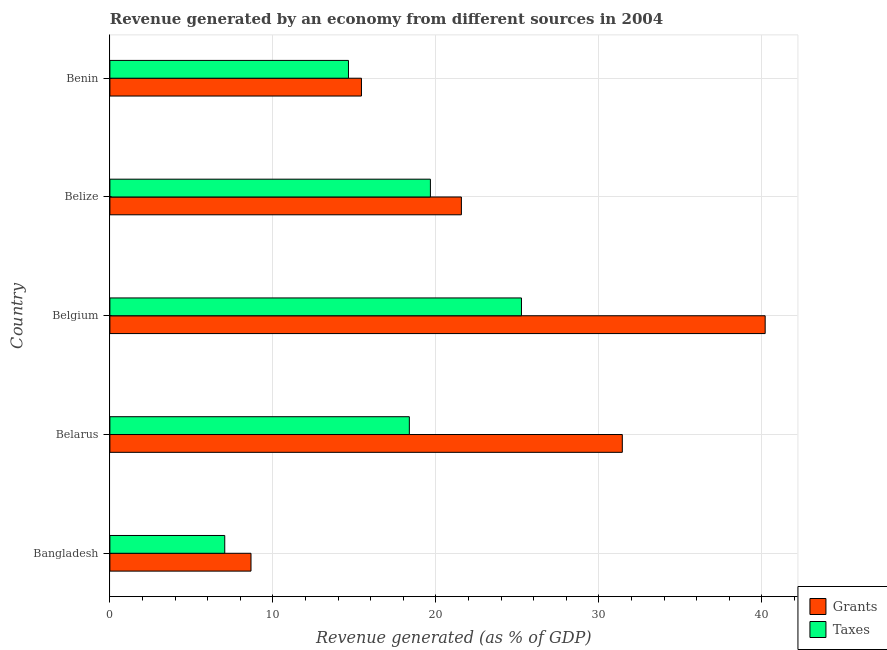How many different coloured bars are there?
Keep it short and to the point. 2. Are the number of bars per tick equal to the number of legend labels?
Your answer should be very brief. Yes. Are the number of bars on each tick of the Y-axis equal?
Offer a terse response. Yes. How many bars are there on the 3rd tick from the bottom?
Give a very brief answer. 2. What is the label of the 2nd group of bars from the top?
Your response must be concise. Belize. What is the revenue generated by grants in Benin?
Your response must be concise. 15.43. Across all countries, what is the maximum revenue generated by taxes?
Your answer should be very brief. 25.25. Across all countries, what is the minimum revenue generated by taxes?
Offer a very short reply. 7.05. What is the total revenue generated by taxes in the graph?
Your response must be concise. 84.97. What is the difference between the revenue generated by grants in Bangladesh and that in Belarus?
Ensure brevity in your answer.  -22.78. What is the difference between the revenue generated by grants in Belgium and the revenue generated by taxes in Belize?
Your response must be concise. 20.54. What is the average revenue generated by taxes per country?
Offer a terse response. 16.99. What is the ratio of the revenue generated by grants in Belarus to that in Benin?
Your answer should be compact. 2.04. Is the difference between the revenue generated by grants in Bangladesh and Belarus greater than the difference between the revenue generated by taxes in Bangladesh and Belarus?
Ensure brevity in your answer.  No. What is the difference between the highest and the second highest revenue generated by grants?
Provide a succinct answer. 8.76. Is the sum of the revenue generated by taxes in Bangladesh and Belgium greater than the maximum revenue generated by grants across all countries?
Your answer should be very brief. No. What does the 1st bar from the top in Benin represents?
Make the answer very short. Taxes. What does the 2nd bar from the bottom in Belize represents?
Provide a succinct answer. Taxes. How many bars are there?
Offer a terse response. 10. Are all the bars in the graph horizontal?
Provide a succinct answer. Yes. How many countries are there in the graph?
Offer a very short reply. 5. What is the difference between two consecutive major ticks on the X-axis?
Provide a succinct answer. 10. Are the values on the major ticks of X-axis written in scientific E-notation?
Your answer should be compact. No. Does the graph contain grids?
Offer a terse response. Yes. How are the legend labels stacked?
Ensure brevity in your answer.  Vertical. What is the title of the graph?
Your answer should be very brief. Revenue generated by an economy from different sources in 2004. Does "Savings" appear as one of the legend labels in the graph?
Provide a succinct answer. No. What is the label or title of the X-axis?
Your answer should be very brief. Revenue generated (as % of GDP). What is the label or title of the Y-axis?
Your answer should be very brief. Country. What is the Revenue generated (as % of GDP) in Grants in Bangladesh?
Offer a very short reply. 8.66. What is the Revenue generated (as % of GDP) in Taxes in Bangladesh?
Offer a terse response. 7.05. What is the Revenue generated (as % of GDP) in Grants in Belarus?
Make the answer very short. 31.44. What is the Revenue generated (as % of GDP) in Taxes in Belarus?
Your answer should be compact. 18.37. What is the Revenue generated (as % of GDP) of Grants in Belgium?
Provide a succinct answer. 40.2. What is the Revenue generated (as % of GDP) of Taxes in Belgium?
Your answer should be compact. 25.25. What is the Revenue generated (as % of GDP) in Grants in Belize?
Provide a short and direct response. 21.56. What is the Revenue generated (as % of GDP) of Taxes in Belize?
Provide a short and direct response. 19.66. What is the Revenue generated (as % of GDP) in Grants in Benin?
Make the answer very short. 15.43. What is the Revenue generated (as % of GDP) of Taxes in Benin?
Your answer should be compact. 14.64. Across all countries, what is the maximum Revenue generated (as % of GDP) in Grants?
Your answer should be very brief. 40.2. Across all countries, what is the maximum Revenue generated (as % of GDP) of Taxes?
Your answer should be compact. 25.25. Across all countries, what is the minimum Revenue generated (as % of GDP) in Grants?
Give a very brief answer. 8.66. Across all countries, what is the minimum Revenue generated (as % of GDP) of Taxes?
Offer a terse response. 7.05. What is the total Revenue generated (as % of GDP) of Grants in the graph?
Offer a very short reply. 117.29. What is the total Revenue generated (as % of GDP) in Taxes in the graph?
Your answer should be very brief. 84.97. What is the difference between the Revenue generated (as % of GDP) of Grants in Bangladesh and that in Belarus?
Provide a short and direct response. -22.78. What is the difference between the Revenue generated (as % of GDP) of Taxes in Bangladesh and that in Belarus?
Your response must be concise. -11.32. What is the difference between the Revenue generated (as % of GDP) in Grants in Bangladesh and that in Belgium?
Offer a terse response. -31.54. What is the difference between the Revenue generated (as % of GDP) in Taxes in Bangladesh and that in Belgium?
Offer a very short reply. -18.2. What is the difference between the Revenue generated (as % of GDP) in Grants in Bangladesh and that in Belize?
Your answer should be very brief. -12.91. What is the difference between the Revenue generated (as % of GDP) in Taxes in Bangladesh and that in Belize?
Your answer should be compact. -12.62. What is the difference between the Revenue generated (as % of GDP) of Grants in Bangladesh and that in Benin?
Give a very brief answer. -6.78. What is the difference between the Revenue generated (as % of GDP) of Taxes in Bangladesh and that in Benin?
Provide a short and direct response. -7.59. What is the difference between the Revenue generated (as % of GDP) in Grants in Belarus and that in Belgium?
Your response must be concise. -8.76. What is the difference between the Revenue generated (as % of GDP) in Taxes in Belarus and that in Belgium?
Your answer should be compact. -6.88. What is the difference between the Revenue generated (as % of GDP) of Grants in Belarus and that in Belize?
Offer a terse response. 9.87. What is the difference between the Revenue generated (as % of GDP) of Taxes in Belarus and that in Belize?
Make the answer very short. -1.29. What is the difference between the Revenue generated (as % of GDP) of Grants in Belarus and that in Benin?
Your response must be concise. 16. What is the difference between the Revenue generated (as % of GDP) in Taxes in Belarus and that in Benin?
Your answer should be compact. 3.74. What is the difference between the Revenue generated (as % of GDP) of Grants in Belgium and that in Belize?
Provide a succinct answer. 18.64. What is the difference between the Revenue generated (as % of GDP) of Taxes in Belgium and that in Belize?
Provide a succinct answer. 5.59. What is the difference between the Revenue generated (as % of GDP) of Grants in Belgium and that in Benin?
Offer a very short reply. 24.77. What is the difference between the Revenue generated (as % of GDP) in Taxes in Belgium and that in Benin?
Make the answer very short. 10.61. What is the difference between the Revenue generated (as % of GDP) of Grants in Belize and that in Benin?
Your answer should be compact. 6.13. What is the difference between the Revenue generated (as % of GDP) of Taxes in Belize and that in Benin?
Make the answer very short. 5.03. What is the difference between the Revenue generated (as % of GDP) in Grants in Bangladesh and the Revenue generated (as % of GDP) in Taxes in Belarus?
Make the answer very short. -9.71. What is the difference between the Revenue generated (as % of GDP) in Grants in Bangladesh and the Revenue generated (as % of GDP) in Taxes in Belgium?
Offer a very short reply. -16.59. What is the difference between the Revenue generated (as % of GDP) of Grants in Bangladesh and the Revenue generated (as % of GDP) of Taxes in Belize?
Give a very brief answer. -11.01. What is the difference between the Revenue generated (as % of GDP) in Grants in Bangladesh and the Revenue generated (as % of GDP) in Taxes in Benin?
Your answer should be very brief. -5.98. What is the difference between the Revenue generated (as % of GDP) of Grants in Belarus and the Revenue generated (as % of GDP) of Taxes in Belgium?
Offer a very short reply. 6.19. What is the difference between the Revenue generated (as % of GDP) in Grants in Belarus and the Revenue generated (as % of GDP) in Taxes in Belize?
Your answer should be very brief. 11.77. What is the difference between the Revenue generated (as % of GDP) in Grants in Belarus and the Revenue generated (as % of GDP) in Taxes in Benin?
Offer a very short reply. 16.8. What is the difference between the Revenue generated (as % of GDP) of Grants in Belgium and the Revenue generated (as % of GDP) of Taxes in Belize?
Provide a short and direct response. 20.54. What is the difference between the Revenue generated (as % of GDP) of Grants in Belgium and the Revenue generated (as % of GDP) of Taxes in Benin?
Your answer should be very brief. 25.56. What is the difference between the Revenue generated (as % of GDP) in Grants in Belize and the Revenue generated (as % of GDP) in Taxes in Benin?
Your answer should be very brief. 6.93. What is the average Revenue generated (as % of GDP) in Grants per country?
Your response must be concise. 23.46. What is the average Revenue generated (as % of GDP) of Taxes per country?
Your answer should be very brief. 16.99. What is the difference between the Revenue generated (as % of GDP) of Grants and Revenue generated (as % of GDP) of Taxes in Bangladesh?
Offer a very short reply. 1.61. What is the difference between the Revenue generated (as % of GDP) in Grants and Revenue generated (as % of GDP) in Taxes in Belarus?
Keep it short and to the point. 13.06. What is the difference between the Revenue generated (as % of GDP) in Grants and Revenue generated (as % of GDP) in Taxes in Belgium?
Give a very brief answer. 14.95. What is the difference between the Revenue generated (as % of GDP) of Grants and Revenue generated (as % of GDP) of Taxes in Belize?
Make the answer very short. 1.9. What is the difference between the Revenue generated (as % of GDP) in Grants and Revenue generated (as % of GDP) in Taxes in Benin?
Give a very brief answer. 0.8. What is the ratio of the Revenue generated (as % of GDP) in Grants in Bangladesh to that in Belarus?
Ensure brevity in your answer.  0.28. What is the ratio of the Revenue generated (as % of GDP) of Taxes in Bangladesh to that in Belarus?
Provide a succinct answer. 0.38. What is the ratio of the Revenue generated (as % of GDP) of Grants in Bangladesh to that in Belgium?
Give a very brief answer. 0.22. What is the ratio of the Revenue generated (as % of GDP) of Taxes in Bangladesh to that in Belgium?
Offer a terse response. 0.28. What is the ratio of the Revenue generated (as % of GDP) of Grants in Bangladesh to that in Belize?
Keep it short and to the point. 0.4. What is the ratio of the Revenue generated (as % of GDP) of Taxes in Bangladesh to that in Belize?
Give a very brief answer. 0.36. What is the ratio of the Revenue generated (as % of GDP) in Grants in Bangladesh to that in Benin?
Your answer should be compact. 0.56. What is the ratio of the Revenue generated (as % of GDP) of Taxes in Bangladesh to that in Benin?
Your answer should be compact. 0.48. What is the ratio of the Revenue generated (as % of GDP) of Grants in Belarus to that in Belgium?
Give a very brief answer. 0.78. What is the ratio of the Revenue generated (as % of GDP) in Taxes in Belarus to that in Belgium?
Make the answer very short. 0.73. What is the ratio of the Revenue generated (as % of GDP) of Grants in Belarus to that in Belize?
Ensure brevity in your answer.  1.46. What is the ratio of the Revenue generated (as % of GDP) in Taxes in Belarus to that in Belize?
Ensure brevity in your answer.  0.93. What is the ratio of the Revenue generated (as % of GDP) in Grants in Belarus to that in Benin?
Offer a very short reply. 2.04. What is the ratio of the Revenue generated (as % of GDP) in Taxes in Belarus to that in Benin?
Offer a very short reply. 1.26. What is the ratio of the Revenue generated (as % of GDP) of Grants in Belgium to that in Belize?
Keep it short and to the point. 1.86. What is the ratio of the Revenue generated (as % of GDP) of Taxes in Belgium to that in Belize?
Your answer should be very brief. 1.28. What is the ratio of the Revenue generated (as % of GDP) of Grants in Belgium to that in Benin?
Your answer should be very brief. 2.6. What is the ratio of the Revenue generated (as % of GDP) of Taxes in Belgium to that in Benin?
Make the answer very short. 1.73. What is the ratio of the Revenue generated (as % of GDP) in Grants in Belize to that in Benin?
Provide a short and direct response. 1.4. What is the ratio of the Revenue generated (as % of GDP) in Taxes in Belize to that in Benin?
Ensure brevity in your answer.  1.34. What is the difference between the highest and the second highest Revenue generated (as % of GDP) of Grants?
Make the answer very short. 8.76. What is the difference between the highest and the second highest Revenue generated (as % of GDP) of Taxes?
Make the answer very short. 5.59. What is the difference between the highest and the lowest Revenue generated (as % of GDP) of Grants?
Offer a very short reply. 31.54. What is the difference between the highest and the lowest Revenue generated (as % of GDP) of Taxes?
Give a very brief answer. 18.2. 